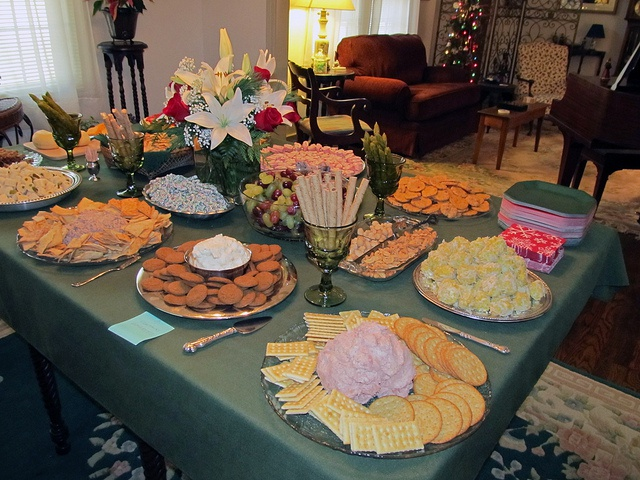Describe the objects in this image and their specific colors. I can see dining table in lavender, black, gray, and tan tones, potted plant in lavender, black, darkgray, and tan tones, chair in lavender, black, maroon, and brown tones, bowl in lavender, tan, black, gray, and maroon tones, and chair in lavender, black, tan, and maroon tones in this image. 